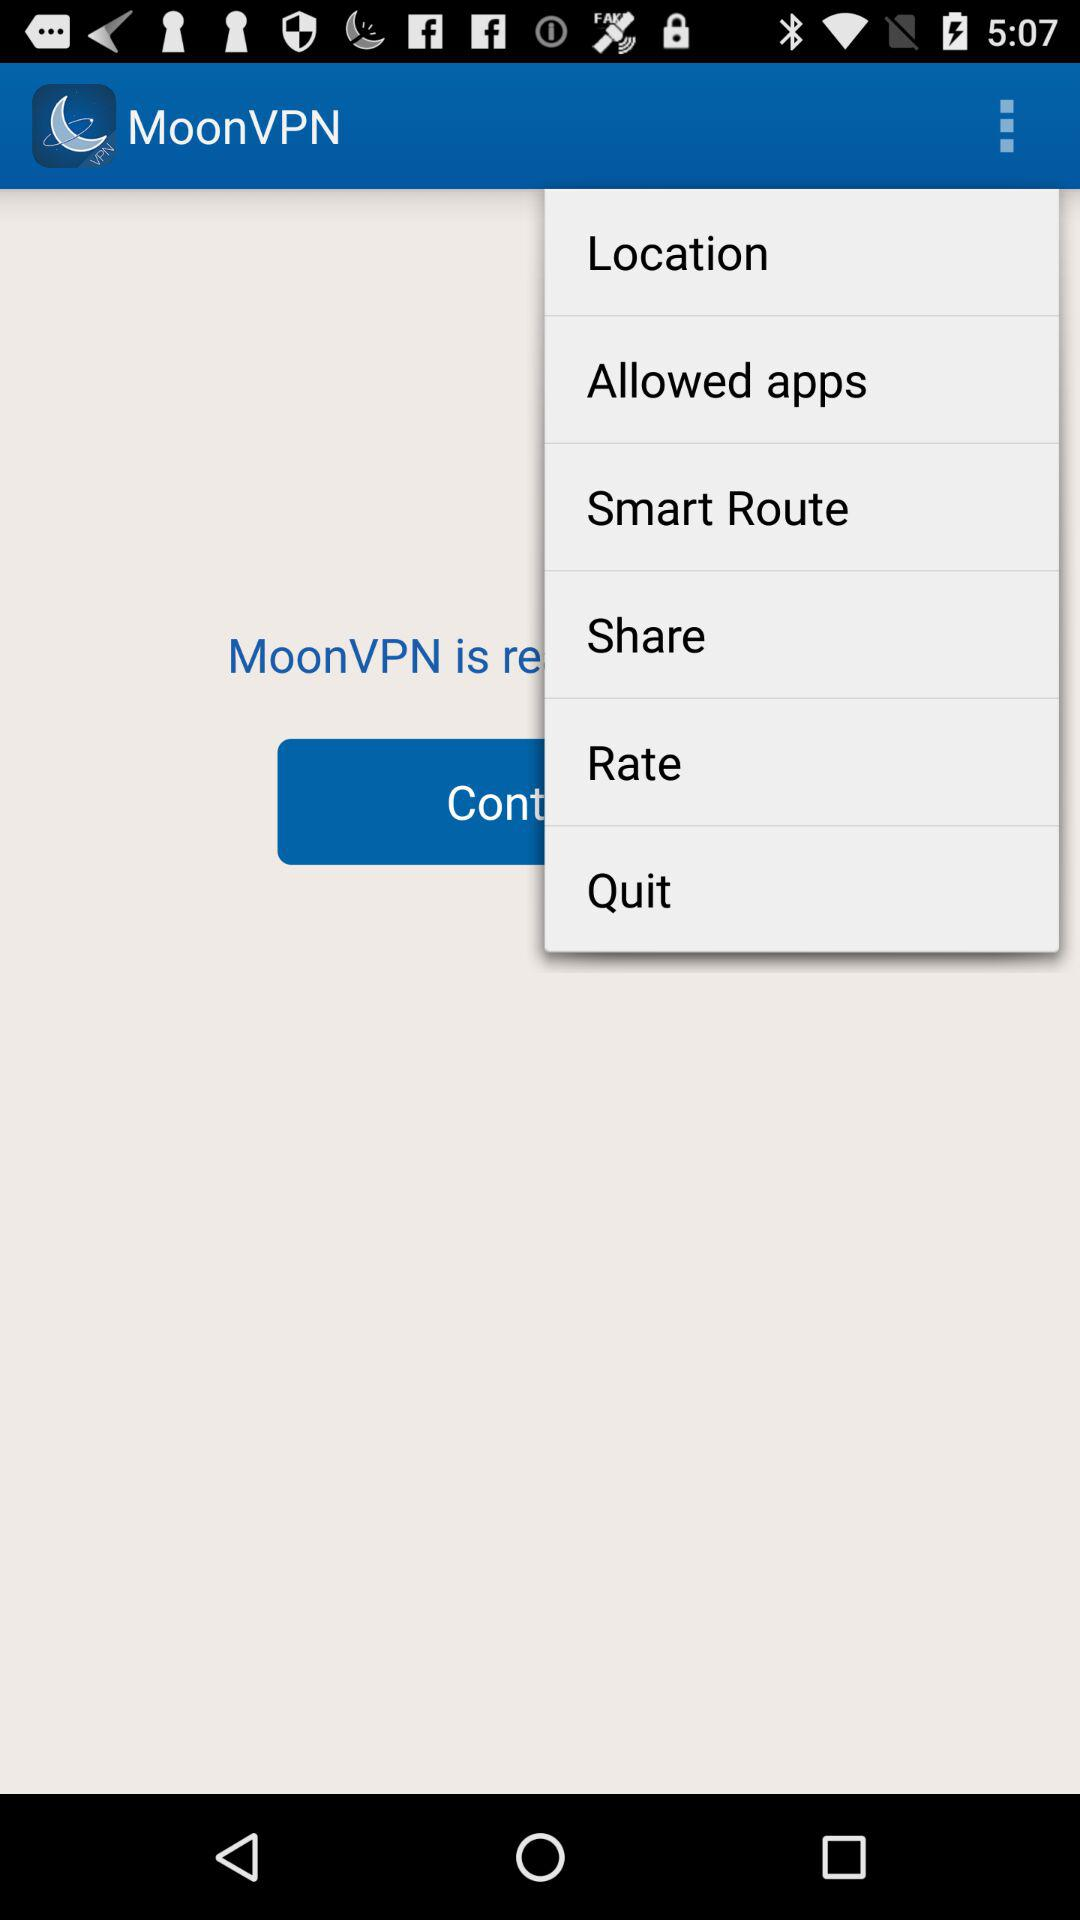What is the application name? The name of the application is "MoonVPN". 